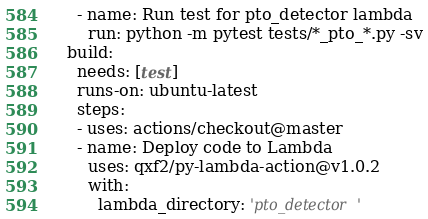<code> <loc_0><loc_0><loc_500><loc_500><_YAML_>    - name: Run test for pto_detector lambda
      run: python -m pytest tests/*_pto_*.py -sv
  build:
    needs: [test]
    runs-on: ubuntu-latest
    steps:
    - uses: actions/checkout@master
    - name: Deploy code to Lambda
      uses: qxf2/py-lambda-action@v1.0.2
      with:
        lambda_directory: 'pto_detector'</code> 